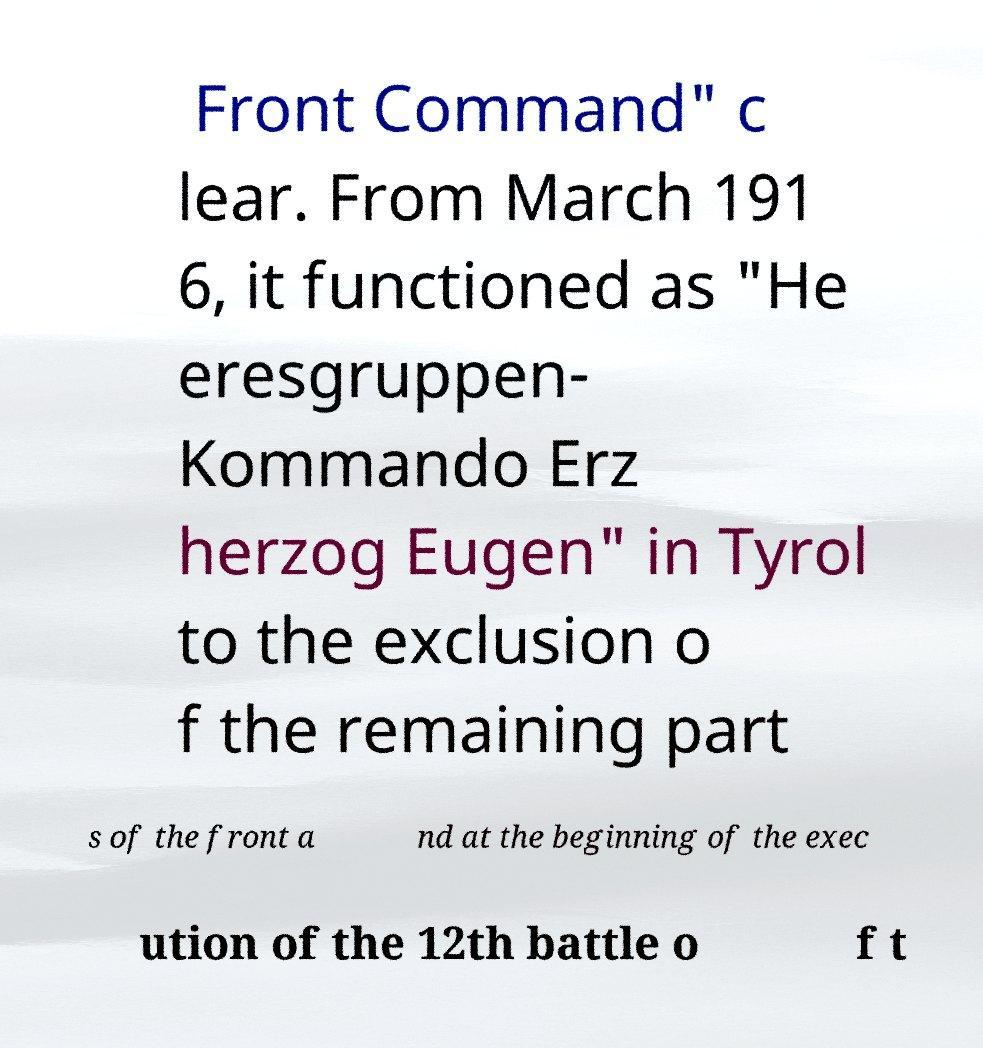Can you read and provide the text displayed in the image?This photo seems to have some interesting text. Can you extract and type it out for me? Front Command" c lear. From March 191 6, it functioned as "He eresgruppen- Kommando Erz herzog Eugen" in Tyrol to the exclusion o f the remaining part s of the front a nd at the beginning of the exec ution of the 12th battle o f t 